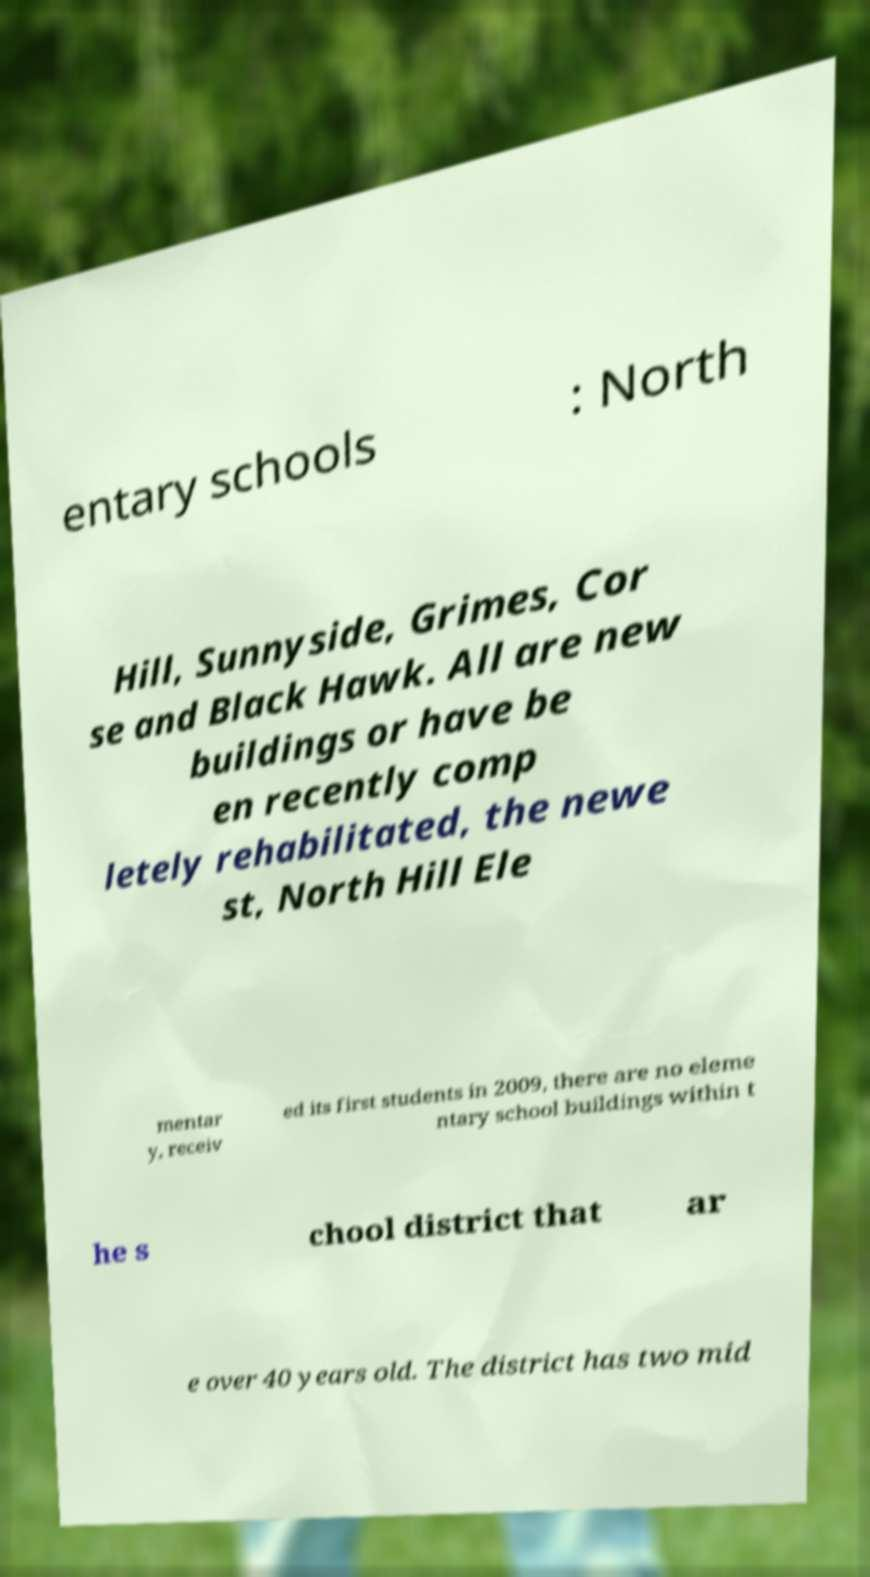For documentation purposes, I need the text within this image transcribed. Could you provide that? entary schools : North Hill, Sunnyside, Grimes, Cor se and Black Hawk. All are new buildings or have be en recently comp letely rehabilitated, the newe st, North Hill Ele mentar y, receiv ed its first students in 2009, there are no eleme ntary school buildings within t he s chool district that ar e over 40 years old. The district has two mid 